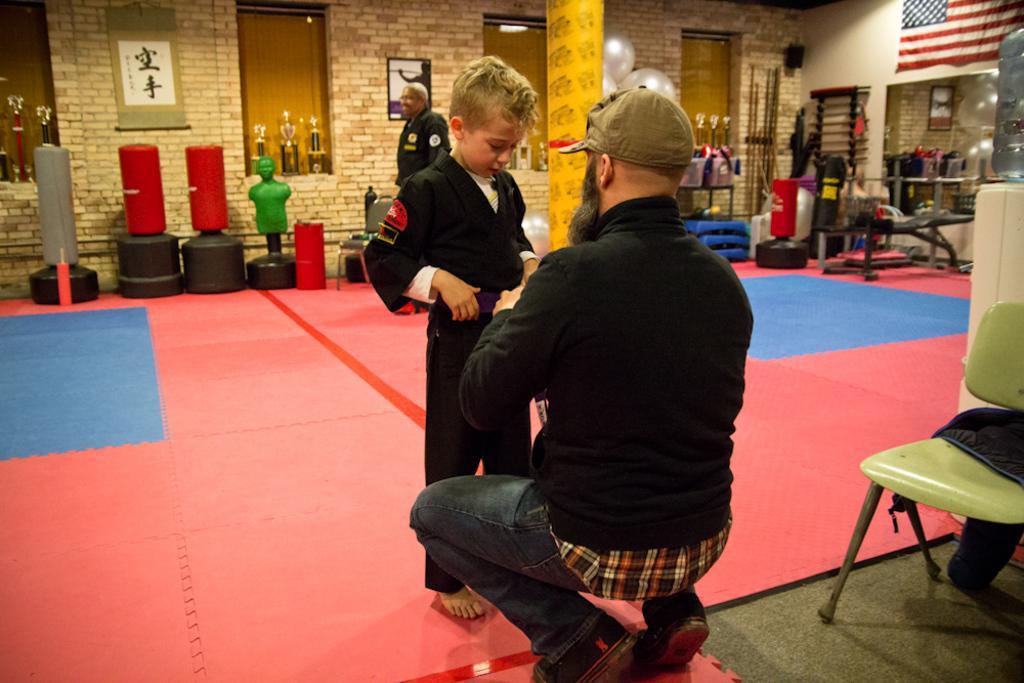How would you summarize this image in a sentence or two? a person is wearing a black shirt. in front of him a person is standing wearing a black dress. behind him there a person standing. at the back there is a brick wall and a photo frame. at the right there is a mirror , above that there is a flag. in the right front there is a green chair. 